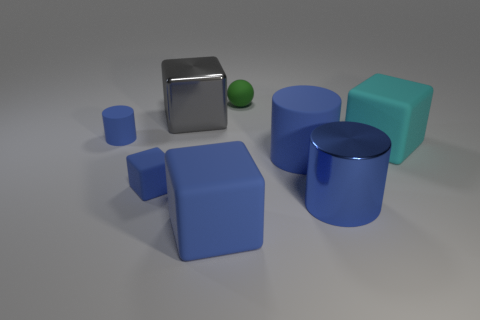Subtract all blue cylinders. How many were subtracted if there are1blue cylinders left? 2 Add 1 brown matte cylinders. How many objects exist? 9 Subtract all cylinders. How many objects are left? 5 Subtract all large metal things. Subtract all tiny green rubber balls. How many objects are left? 5 Add 5 green rubber objects. How many green rubber objects are left? 6 Add 7 small brown matte balls. How many small brown matte balls exist? 7 Subtract 0 brown cubes. How many objects are left? 8 